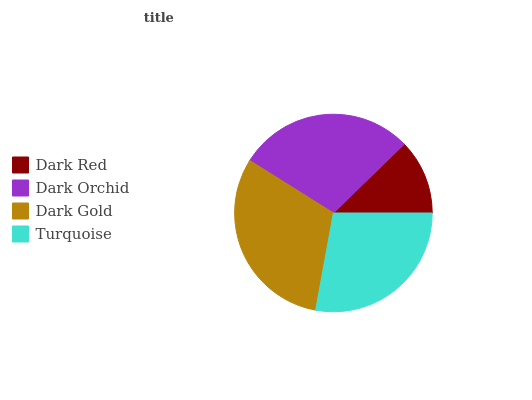Is Dark Red the minimum?
Answer yes or no. Yes. Is Dark Gold the maximum?
Answer yes or no. Yes. Is Dark Orchid the minimum?
Answer yes or no. No. Is Dark Orchid the maximum?
Answer yes or no. No. Is Dark Orchid greater than Dark Red?
Answer yes or no. Yes. Is Dark Red less than Dark Orchid?
Answer yes or no. Yes. Is Dark Red greater than Dark Orchid?
Answer yes or no. No. Is Dark Orchid less than Dark Red?
Answer yes or no. No. Is Dark Orchid the high median?
Answer yes or no. Yes. Is Turquoise the low median?
Answer yes or no. Yes. Is Turquoise the high median?
Answer yes or no. No. Is Dark Orchid the low median?
Answer yes or no. No. 